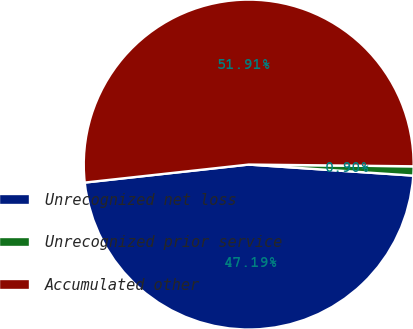Convert chart to OTSL. <chart><loc_0><loc_0><loc_500><loc_500><pie_chart><fcel>Unrecognized net loss<fcel>Unrecognized prior service<fcel>Accumulated other<nl><fcel>47.19%<fcel>0.9%<fcel>51.91%<nl></chart> 